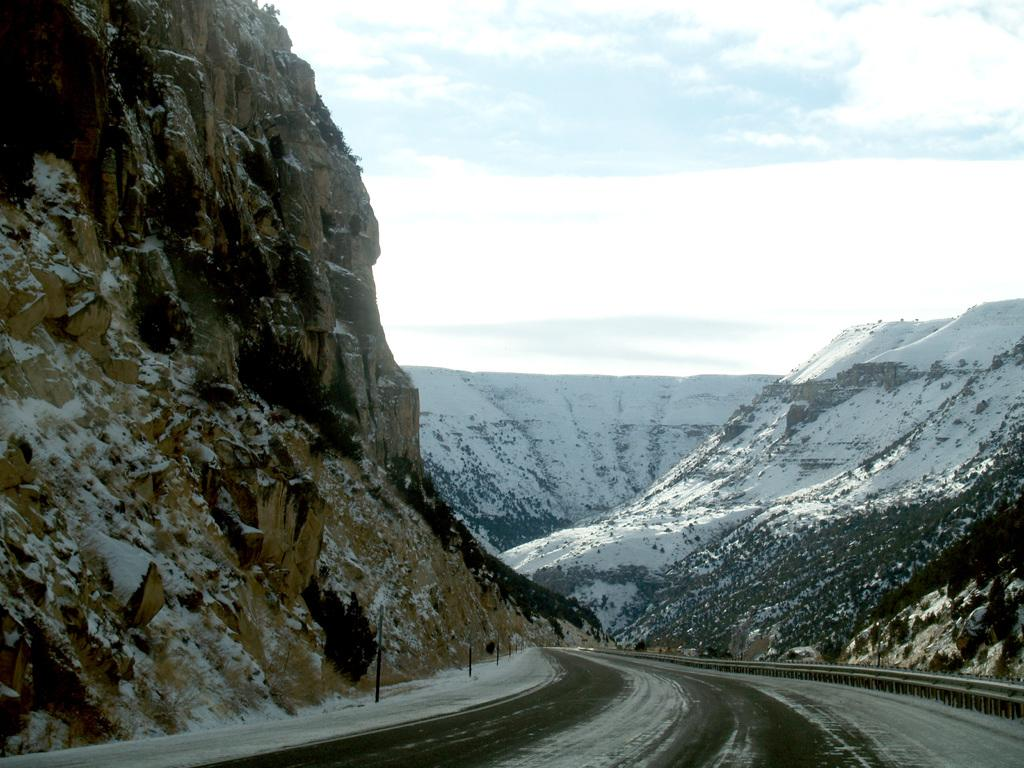What type of natural feature is visible in the image? There are mountains in the image. What is the condition of the mountains in the image? The mountains are covered with snow. Can you describe the path in the image? There is a path in the image, and it has fencing alongside it. What is the weather like in the image? The sky is cloudy in the image. How many spades are being used to pull the cart in the image? There is no cart or spades present in the image; it features mountains, a path, and fencing. 